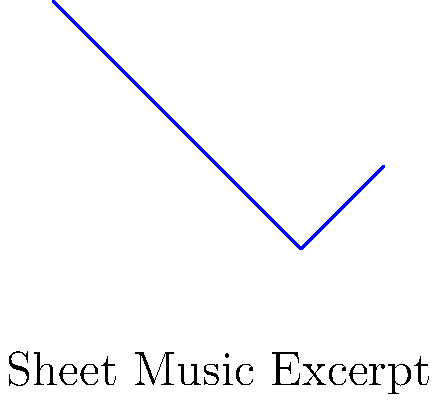Which famous Schubert piano work does this sheet music excerpt likely belong to? 1. Observe the melodic contour: The excerpt shows a descending line followed by a slight rise.
2. Note the simple, lyrical nature of the melody, typical of Schubert's style.
3. The rhythm appears to be mostly quarter notes, suggesting a moderate tempo.
4. This particular melodic shape and simplicity is characteristic of Schubert's "Ave Maria."
5. "Ave Maria" is one of Schubert's most recognizable and frequently performed piano works.
6. The piece, originally titled "Ellens dritter Gesang" (Ellen's Third Song), is part of his Opus 52, a setting of Sir Walter Scott's poem "The Lady of the Lake."
7. While this excerpt is simplified, it captures the essence of the opening melody of "Ave Maria."
Answer: Ave Maria 